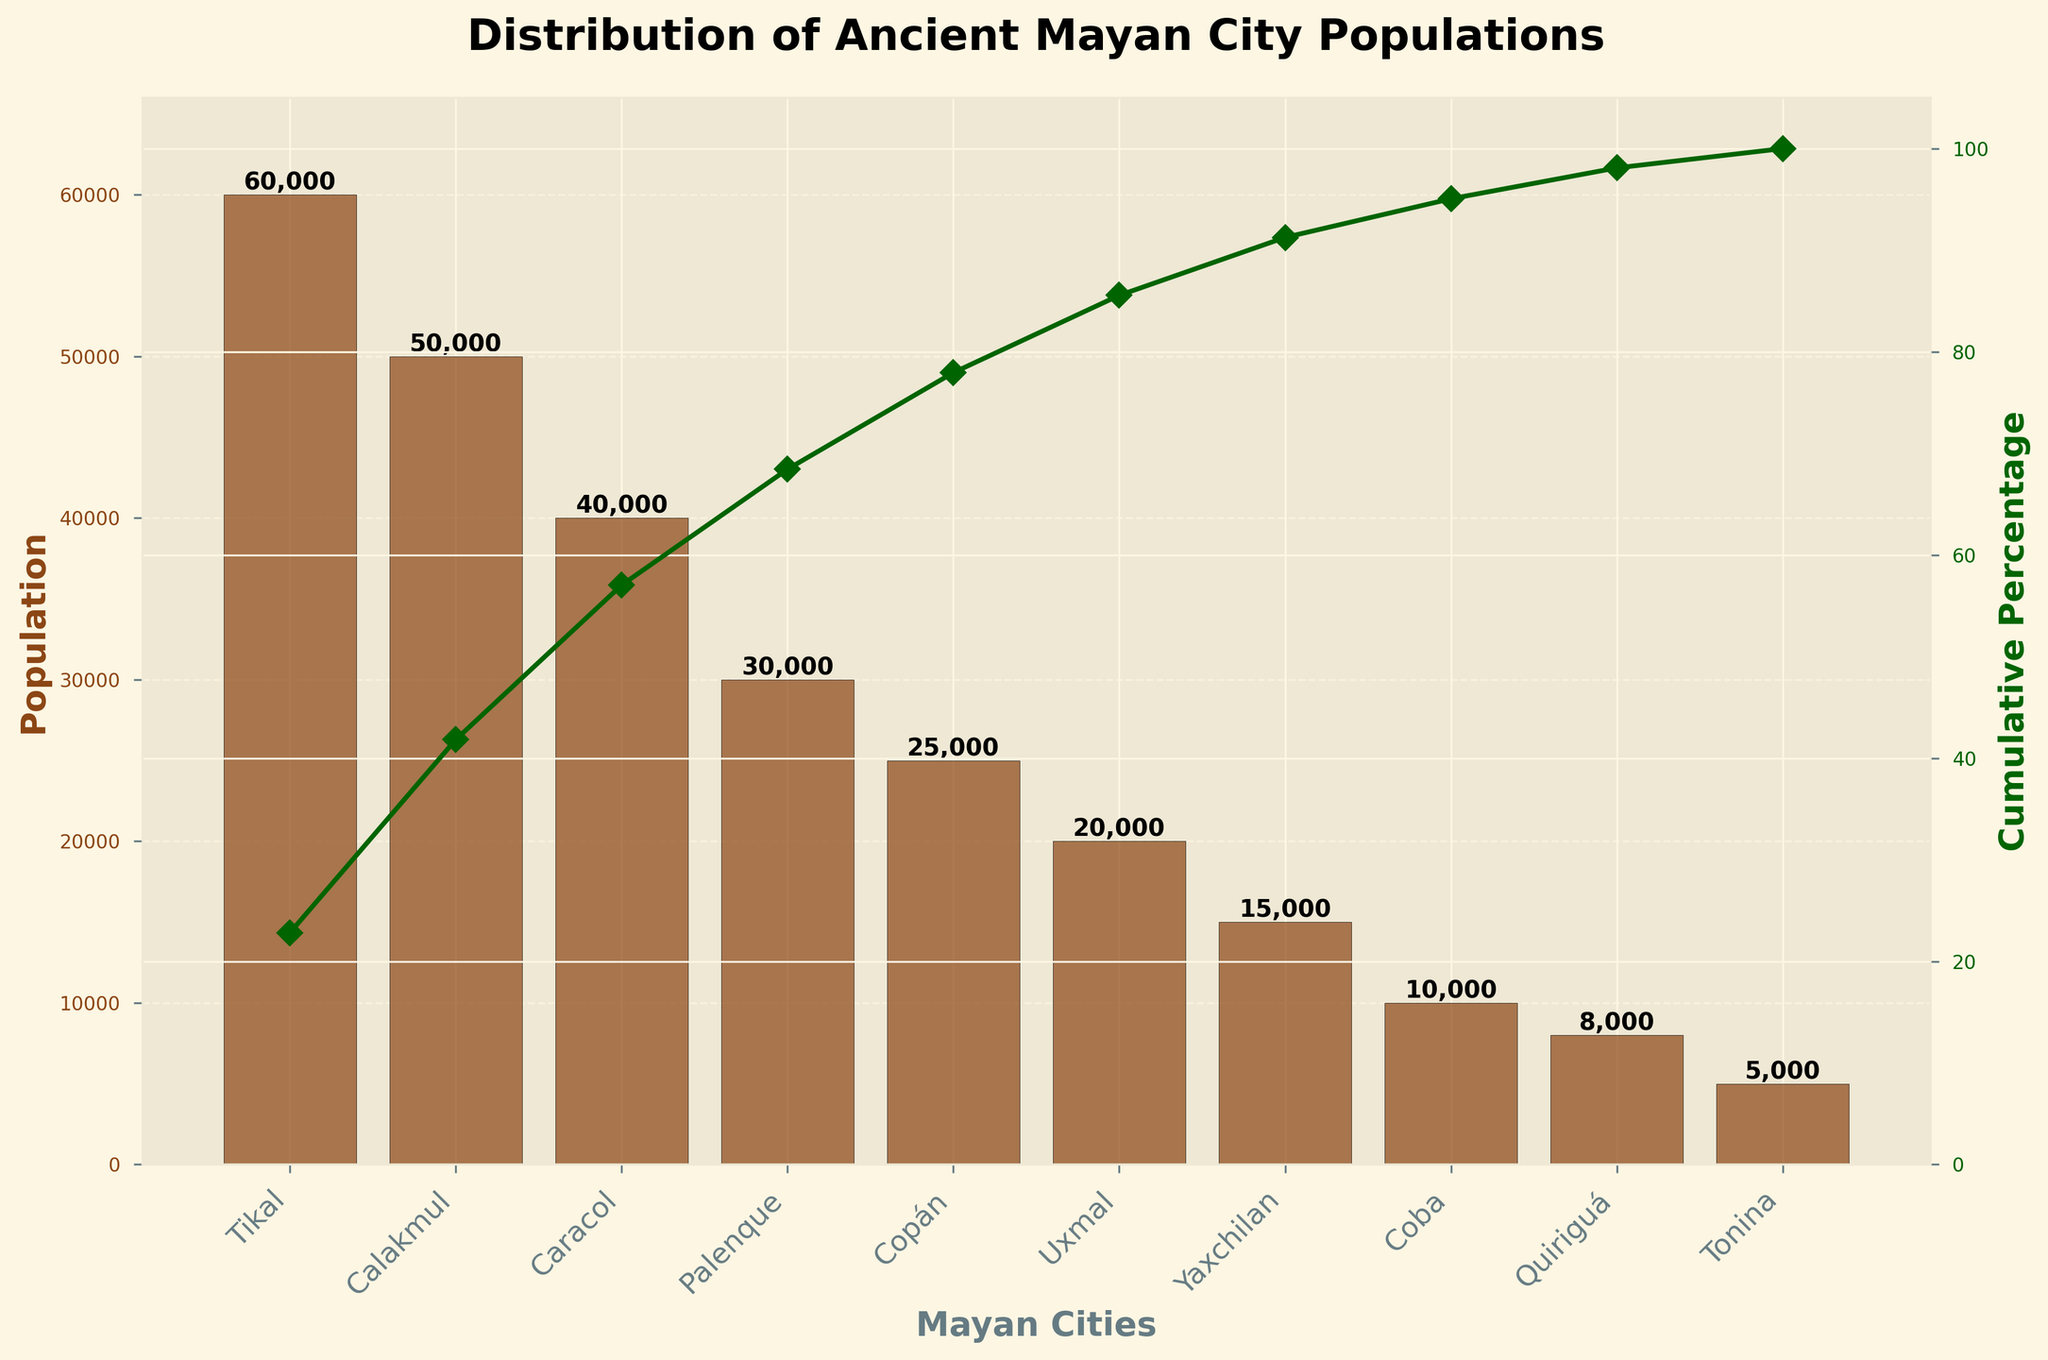What's the title of the figure? The title of the figure is displayed at the top and reads "Distribution of Ancient Mayan City Populations".
Answer: Distribution of Ancient Mayan City Populations What does the left y-axis represent? The left y-axis of the figure has the label "Population" which denotes the population numbers for each Mayan city.
Answer: Population What does the right y-axis represent? The right y-axis of the figure has the label "Cumulative Percentage" which denotes the cumulative percentage of the total population.
Answer: Cumulative Percentage Which city has the highest population? The highest bar in the figure represents Tikal, which is also listed in the city labels below the bars, indicating Tikal has the highest population.
Answer: Tikal How many cities have a population greater than 20,000? By observing the height of the bars, Tikal, Calakmul, Caracol, Palenque, and Copán all have populations greater than 20,000, which amounts to 5 cities.
Answer: 5 What's the population difference between Tikal and Copán? By referring to the figure, Tikal has a population of 60,000 and Copán has 25,000. The difference is calculated as 60,000 - 25,000 = 35,000.
Answer: 35,000 Which city marks the 50% cumulative population point on the right y-axis? The cumulative percentage line crosses the 50% mark above the bar for Caracol, meaning Caracol marks the 50% cumulative population point.
Answer: Caracol What is the cumulative population percentage of the top three cities? The cumulative percentage at the top of the Calakmul bar signifies the cumulative population percentage of the top three cities. The marked value is around 71.4%.
Answer: 71.4% Are there more cities with a population under 10,000 or over 30,000? The figure shows 2 cities (Coba and Quiriguá) with populations under 10,000 and 4 cities (Tikal, Calakmul, Caracol, Palenque) with populations over 30,000. Therefore, there are more cities with a population over 30,000.
Answer: over 30,000 Which city has the smallest population, and what is it? The shortest bar represents Tonina which is indicated in the labels below the bars; it has a population of 5,000 based on the value label on top of the bar.
Answer: Tonina, 5,000 